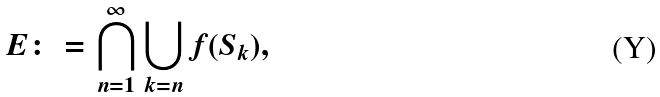<formula> <loc_0><loc_0><loc_500><loc_500>E \colon = \bigcap _ { n = 1 } ^ { \infty } \bigcup _ { k = n } f ( S _ { k } ) ,</formula> 